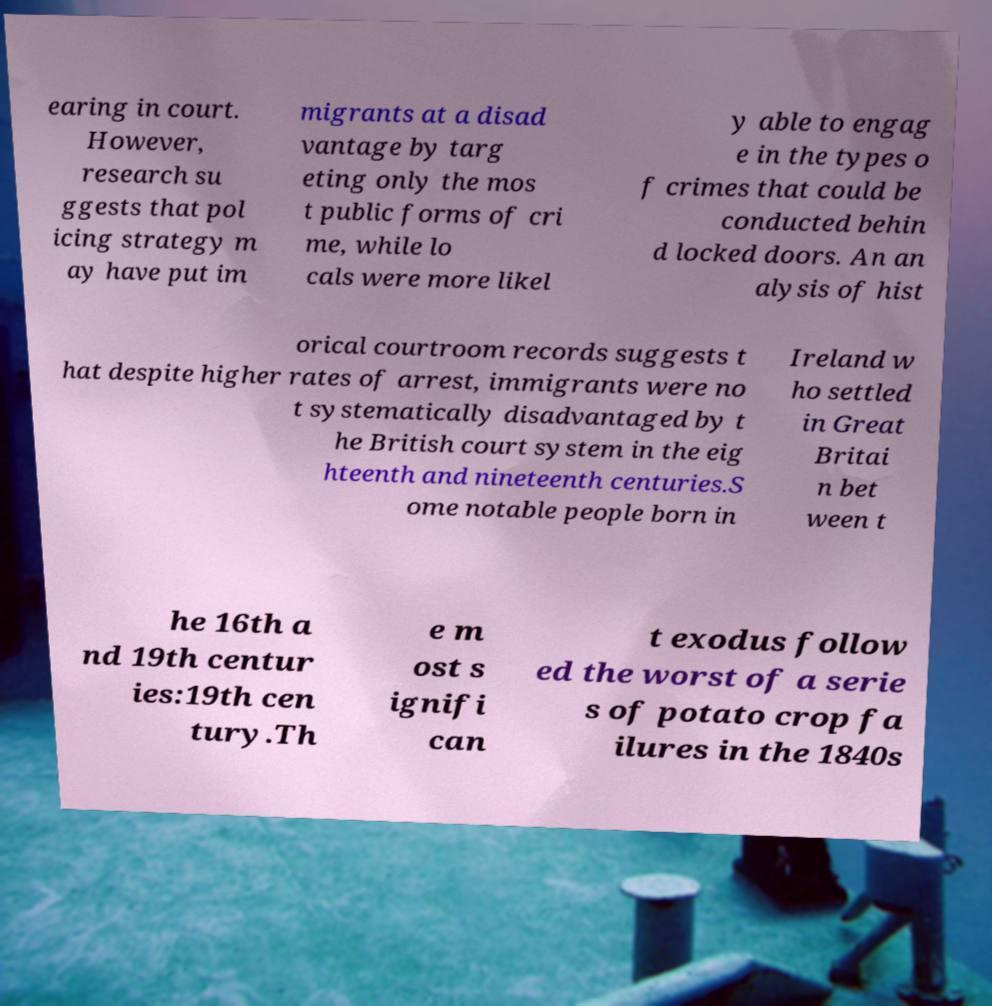For documentation purposes, I need the text within this image transcribed. Could you provide that? earing in court. However, research su ggests that pol icing strategy m ay have put im migrants at a disad vantage by targ eting only the mos t public forms of cri me, while lo cals were more likel y able to engag e in the types o f crimes that could be conducted behin d locked doors. An an alysis of hist orical courtroom records suggests t hat despite higher rates of arrest, immigrants were no t systematically disadvantaged by t he British court system in the eig hteenth and nineteenth centuries.S ome notable people born in Ireland w ho settled in Great Britai n bet ween t he 16th a nd 19th centur ies:19th cen tury.Th e m ost s ignifi can t exodus follow ed the worst of a serie s of potato crop fa ilures in the 1840s 